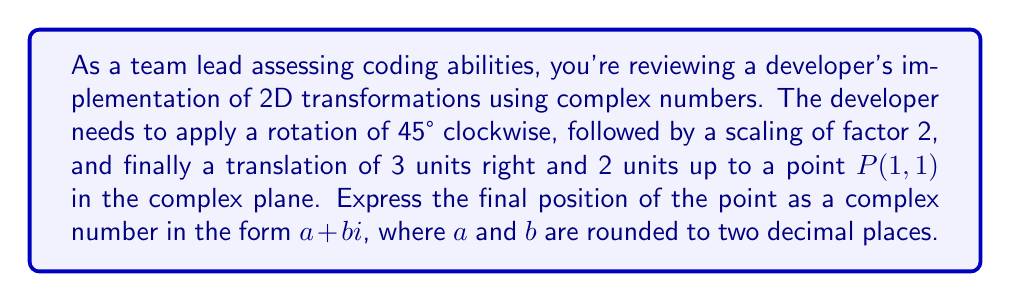Provide a solution to this math problem. Let's approach this step-by-step:

1) First, we represent the initial point $P(1,1)$ as a complex number:
   $z = 1 + i$

2) Rotation by 45° clockwise:
   We multiply by $e^{-i\pi/4}$ (negative angle for clockwise rotation)
   $$z_1 = z \cdot e^{-i\pi/4} = (1+i) \cdot (\cos(-\pi/4) + i\sin(-\pi/4))$$
   $$= (1+i) \cdot (\frac{\sqrt{2}}{2} - i\frac{\sqrt{2}}{2})$$
   $$= (\frac{\sqrt{2}}{2} + \frac{\sqrt{2}}{2}) + (-\frac{\sqrt{2}}{2} + \frac{\sqrt{2}}{2})i = \sqrt{2} + 0i$$

3) Scaling by factor 2:
   We multiply the result by 2
   $$z_2 = 2z_1 = 2\sqrt{2} + 0i$$

4) Translation by 3 units right and 2 units up:
   We add the complex number $(3+2i)$
   $$z_3 = z_2 + (3+2i) = 2\sqrt{2} + 3 + 2i$$

5) Simplify and round to two decimal places:
   $$z_3 = (2\sqrt{2} + 3) + 2i \approx 5.83 + 2.00i$$
Answer: $5.83 + 2.00i$ 